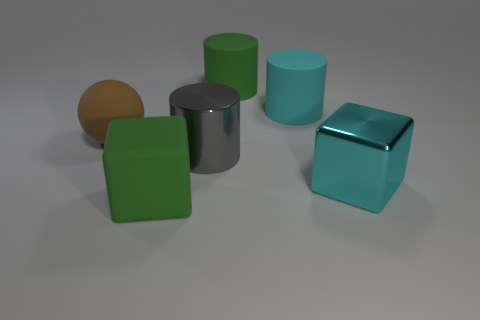Subtract all matte cylinders. How many cylinders are left? 1 Add 3 tiny gray matte blocks. How many objects exist? 9 Subtract all spheres. How many objects are left? 5 Subtract all cyan cubes. How many cubes are left? 1 Subtract 0 red cylinders. How many objects are left? 6 Subtract 2 cubes. How many cubes are left? 0 Subtract all yellow cubes. Subtract all red balls. How many cubes are left? 2 Subtract all red shiny balls. Subtract all gray metal cylinders. How many objects are left? 5 Add 1 big cyan blocks. How many big cyan blocks are left? 2 Add 5 cyan metallic objects. How many cyan metallic objects exist? 6 